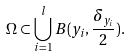<formula> <loc_0><loc_0><loc_500><loc_500>\Omega \subset \bigcup _ { i = 1 } ^ { l } B ( y _ { i } , \frac { \delta _ { y _ { i } } } { 2 } ) .</formula> 